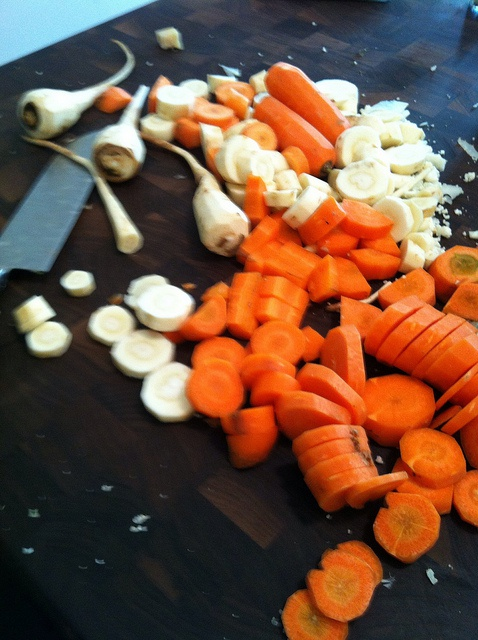Describe the objects in this image and their specific colors. I can see carrot in lightblue, red, brown, and orange tones, carrot in lightblue, red, brown, and salmon tones, carrot in lightblue, red, and maroon tones, knife in lightblue, gray, and black tones, and carrot in lightblue, red, brown, maroon, and salmon tones in this image. 